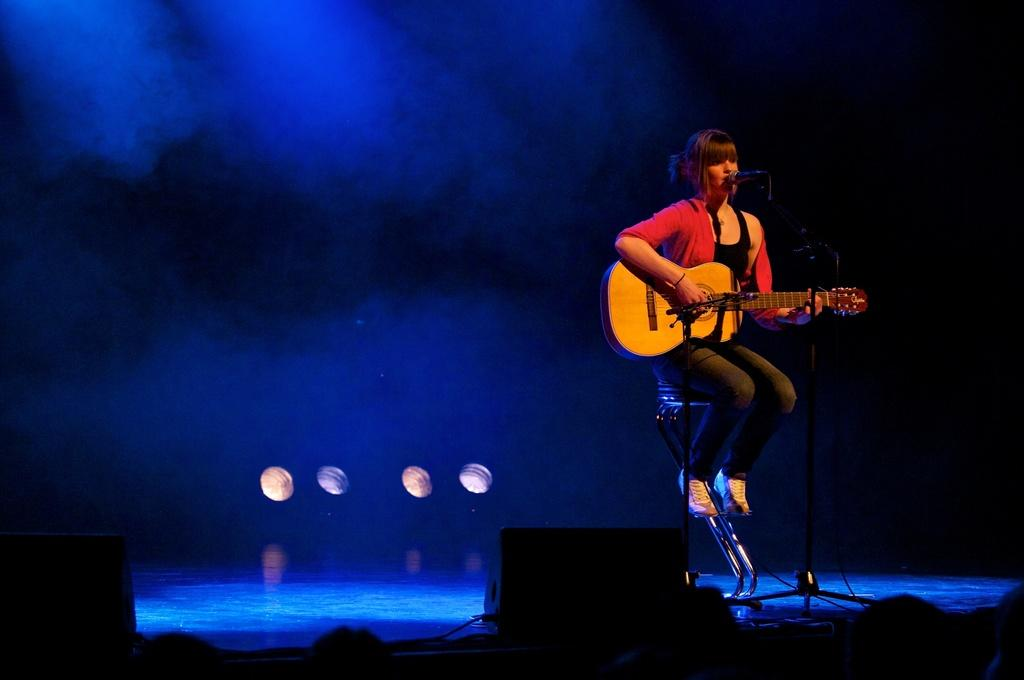What is the person in the image doing? The person is sitting on a chair and playing a guitar. What object is present at the front of the image? There is a microphone at the front of the image. What can be seen at the back of the image? There are lights at the back of the image. What is used for amplifying sound in the image? There are speakers at the front of the image. What type of crime is being committed in the image? There is no crime being committed in the image; it features a person playing a guitar. What rhythm is the person playing on the guitar? The image does not provide information about the rhythm being played on the guitar. 